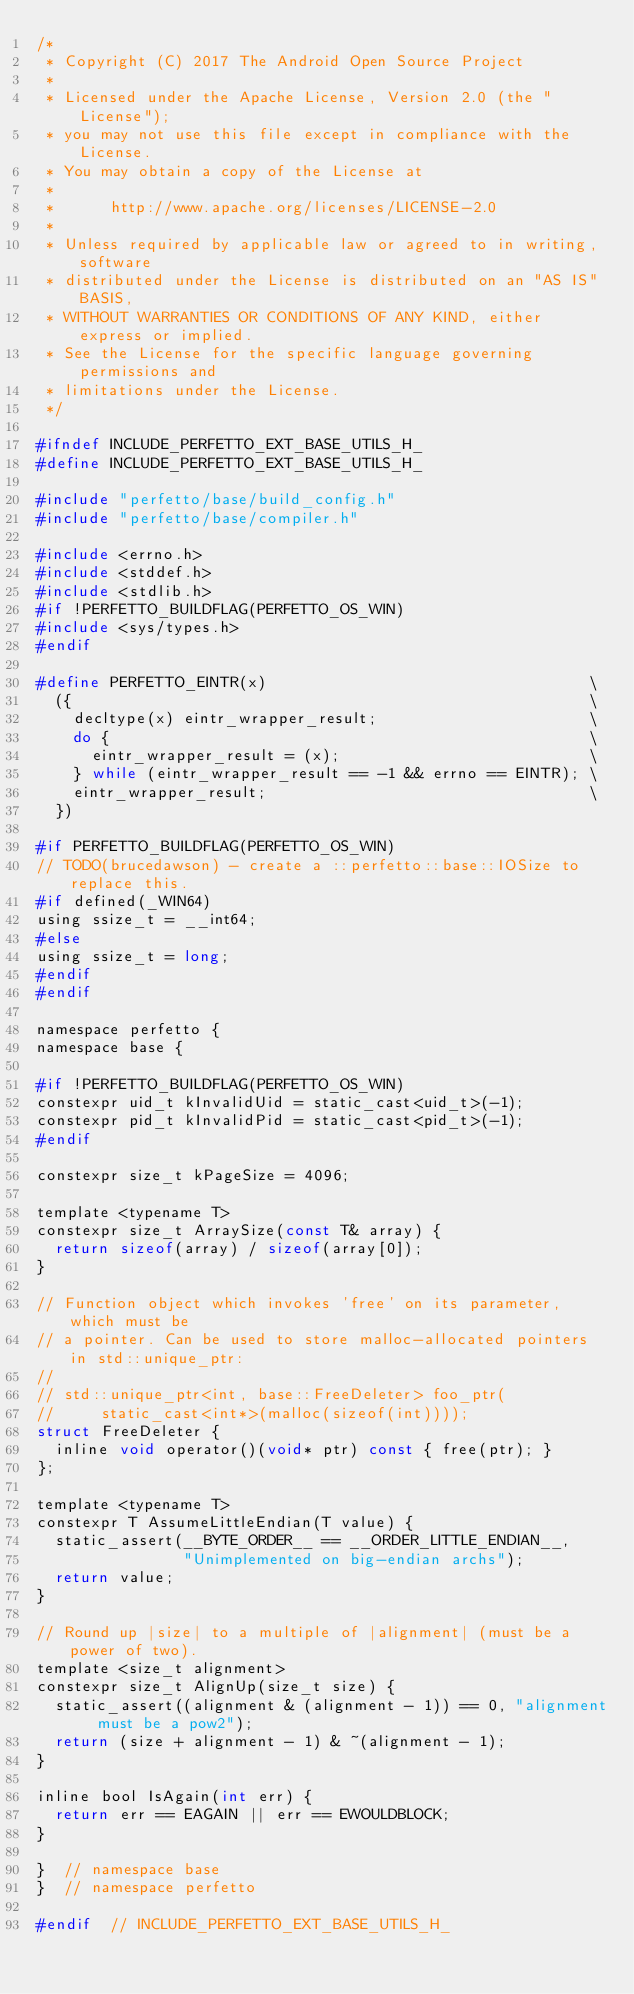Convert code to text. <code><loc_0><loc_0><loc_500><loc_500><_C_>/*
 * Copyright (C) 2017 The Android Open Source Project
 *
 * Licensed under the Apache License, Version 2.0 (the "License");
 * you may not use this file except in compliance with the License.
 * You may obtain a copy of the License at
 *
 *      http://www.apache.org/licenses/LICENSE-2.0
 *
 * Unless required by applicable law or agreed to in writing, software
 * distributed under the License is distributed on an "AS IS" BASIS,
 * WITHOUT WARRANTIES OR CONDITIONS OF ANY KIND, either express or implied.
 * See the License for the specific language governing permissions and
 * limitations under the License.
 */

#ifndef INCLUDE_PERFETTO_EXT_BASE_UTILS_H_
#define INCLUDE_PERFETTO_EXT_BASE_UTILS_H_

#include "perfetto/base/build_config.h"
#include "perfetto/base/compiler.h"

#include <errno.h>
#include <stddef.h>
#include <stdlib.h>
#if !PERFETTO_BUILDFLAG(PERFETTO_OS_WIN)
#include <sys/types.h>
#endif

#define PERFETTO_EINTR(x)                                   \
  ({                                                        \
    decltype(x) eintr_wrapper_result;                       \
    do {                                                    \
      eintr_wrapper_result = (x);                           \
    } while (eintr_wrapper_result == -1 && errno == EINTR); \
    eintr_wrapper_result;                                   \
  })

#if PERFETTO_BUILDFLAG(PERFETTO_OS_WIN)
// TODO(brucedawson) - create a ::perfetto::base::IOSize to replace this.
#if defined(_WIN64)
using ssize_t = __int64;
#else
using ssize_t = long;
#endif
#endif

namespace perfetto {
namespace base {

#if !PERFETTO_BUILDFLAG(PERFETTO_OS_WIN)
constexpr uid_t kInvalidUid = static_cast<uid_t>(-1);
constexpr pid_t kInvalidPid = static_cast<pid_t>(-1);
#endif

constexpr size_t kPageSize = 4096;

template <typename T>
constexpr size_t ArraySize(const T& array) {
  return sizeof(array) / sizeof(array[0]);
}

// Function object which invokes 'free' on its parameter, which must be
// a pointer. Can be used to store malloc-allocated pointers in std::unique_ptr:
//
// std::unique_ptr<int, base::FreeDeleter> foo_ptr(
//     static_cast<int*>(malloc(sizeof(int))));
struct FreeDeleter {
  inline void operator()(void* ptr) const { free(ptr); }
};

template <typename T>
constexpr T AssumeLittleEndian(T value) {
  static_assert(__BYTE_ORDER__ == __ORDER_LITTLE_ENDIAN__,
                "Unimplemented on big-endian archs");
  return value;
}

// Round up |size| to a multiple of |alignment| (must be a power of two).
template <size_t alignment>
constexpr size_t AlignUp(size_t size) {
  static_assert((alignment & (alignment - 1)) == 0, "alignment must be a pow2");
  return (size + alignment - 1) & ~(alignment - 1);
}

inline bool IsAgain(int err) {
  return err == EAGAIN || err == EWOULDBLOCK;
}

}  // namespace base
}  // namespace perfetto

#endif  // INCLUDE_PERFETTO_EXT_BASE_UTILS_H_
</code> 